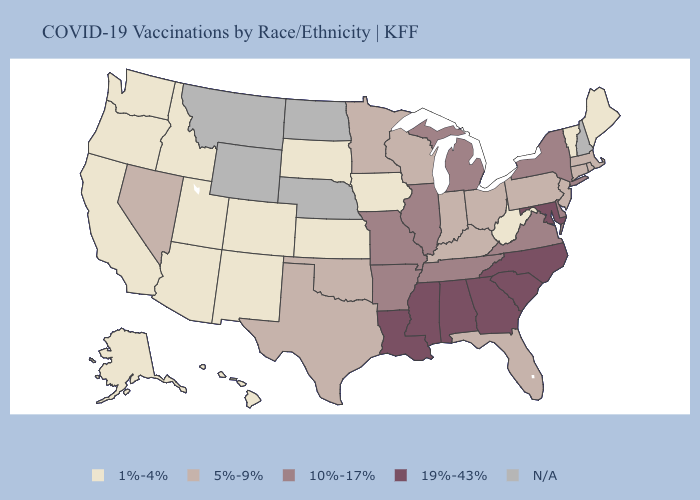Name the states that have a value in the range 10%-17%?
Be succinct. Arkansas, Delaware, Illinois, Michigan, Missouri, New York, Tennessee, Virginia. Does Virginia have the highest value in the USA?
Keep it brief. No. Which states have the lowest value in the USA?
Answer briefly. Alaska, Arizona, California, Colorado, Hawaii, Idaho, Iowa, Kansas, Maine, New Mexico, Oregon, South Dakota, Utah, Vermont, Washington, West Virginia. Does South Carolina have the lowest value in the South?
Concise answer only. No. Which states have the lowest value in the MidWest?
Keep it brief. Iowa, Kansas, South Dakota. Does Georgia have the highest value in the USA?
Short answer required. Yes. What is the highest value in the USA?
Give a very brief answer. 19%-43%. Name the states that have a value in the range N/A?
Quick response, please. Montana, Nebraska, New Hampshire, North Dakota, Wyoming. Is the legend a continuous bar?
Write a very short answer. No. What is the highest value in states that border New Mexico?
Keep it brief. 5%-9%. Name the states that have a value in the range 19%-43%?
Be succinct. Alabama, Georgia, Louisiana, Maryland, Mississippi, North Carolina, South Carolina. What is the highest value in states that border Connecticut?
Concise answer only. 10%-17%. 